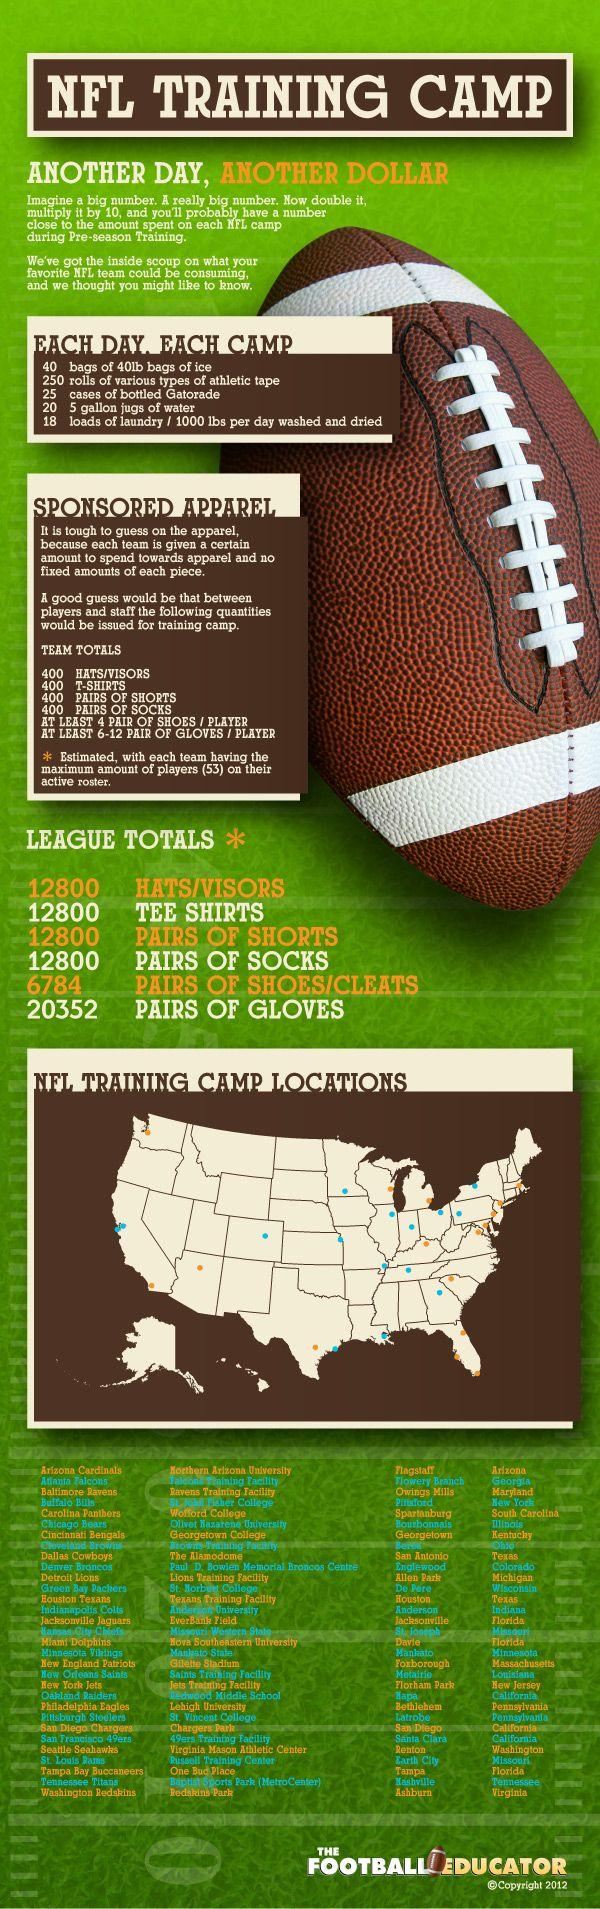Specify some key components in this picture. The NFL Training Camps are held in three stadiums located in California: Hapa, San Diego, and Santa Clara. The quantity of sponsored hats, T-shirts, shorts, and socks for league matches is 12,800. 